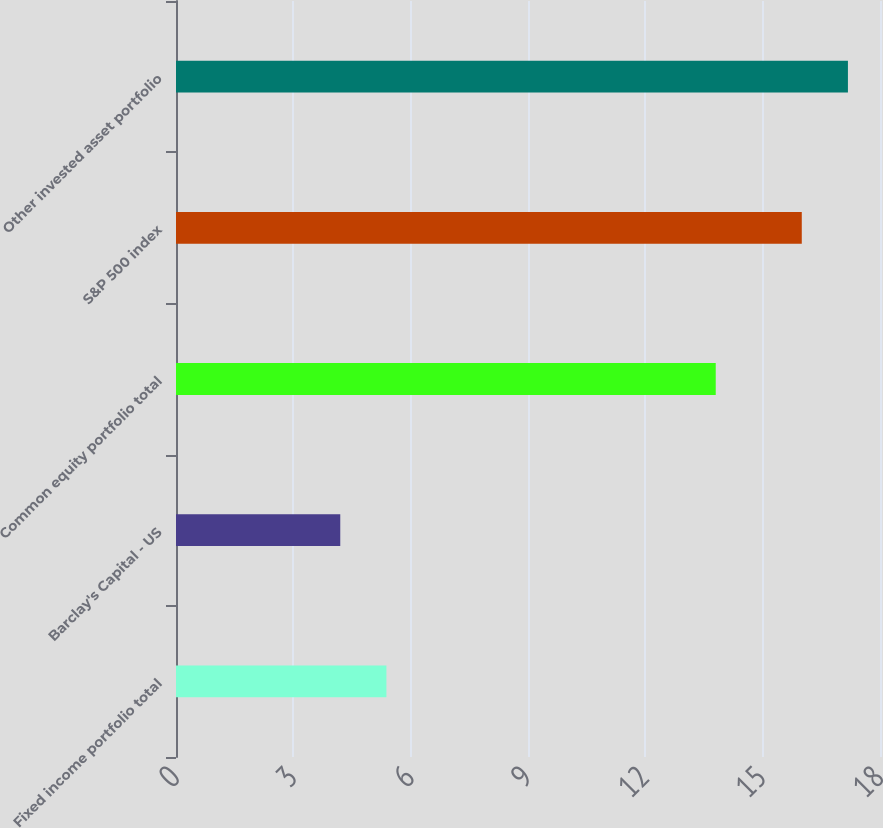<chart> <loc_0><loc_0><loc_500><loc_500><bar_chart><fcel>Fixed income portfolio total<fcel>Barclay's Capital - US<fcel>Common equity portfolio total<fcel>S&P 500 index<fcel>Other invested asset portfolio<nl><fcel>5.38<fcel>4.2<fcel>13.8<fcel>16<fcel>17.18<nl></chart> 